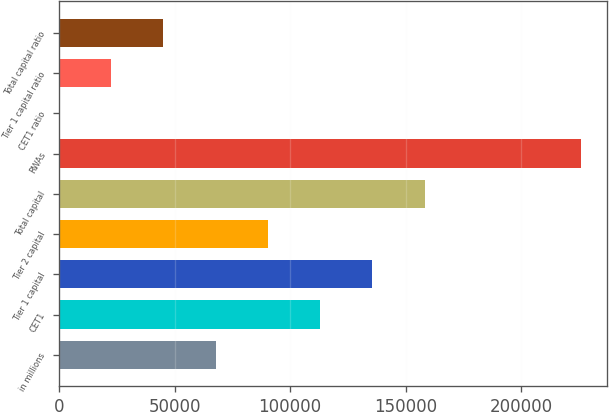Convert chart. <chart><loc_0><loc_0><loc_500><loc_500><bar_chart><fcel>in millions<fcel>CET1<fcel>Tier 1 capital<fcel>Tier 2 capital<fcel>Total capital<fcel>RWAs<fcel>CET1 ratio<fcel>Tier 1 capital ratio<fcel>Total capital ratio<nl><fcel>67790.3<fcel>112976<fcel>135570<fcel>90383.4<fcel>158163<fcel>225942<fcel>11<fcel>22604.1<fcel>45197.2<nl></chart> 